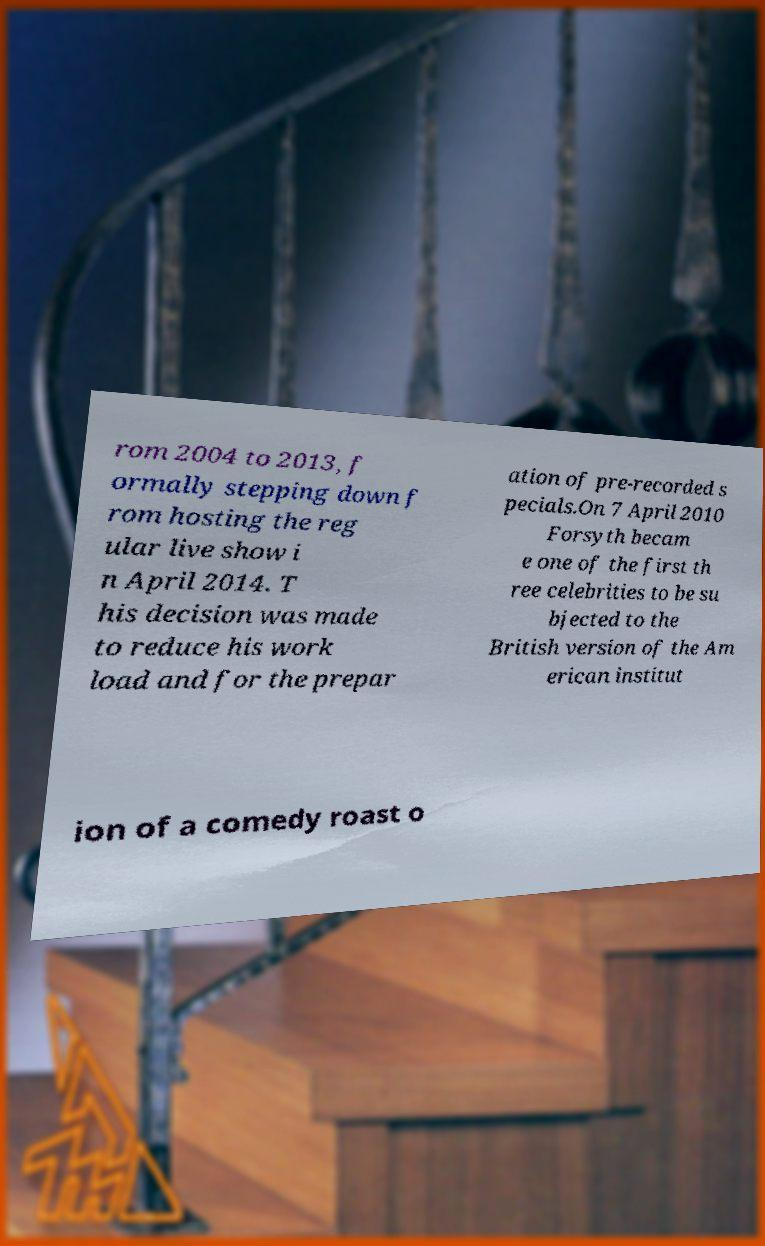Could you extract and type out the text from this image? rom 2004 to 2013, f ormally stepping down f rom hosting the reg ular live show i n April 2014. T his decision was made to reduce his work load and for the prepar ation of pre-recorded s pecials.On 7 April 2010 Forsyth becam e one of the first th ree celebrities to be su bjected to the British version of the Am erican institut ion of a comedy roast o 